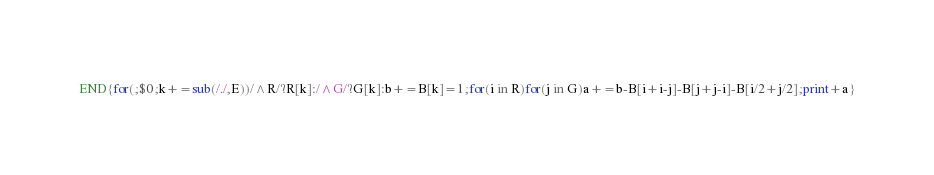Convert code to text. <code><loc_0><loc_0><loc_500><loc_500><_Awk_>END{for(;$0;k+=sub(/./,E))/^R/?R[k]:/^G/?G[k]:b+=B[k]=1;for(i in R)for(j in G)a+=b-B[i+i-j]-B[j+j-i]-B[i/2+j/2];print+a}</code> 